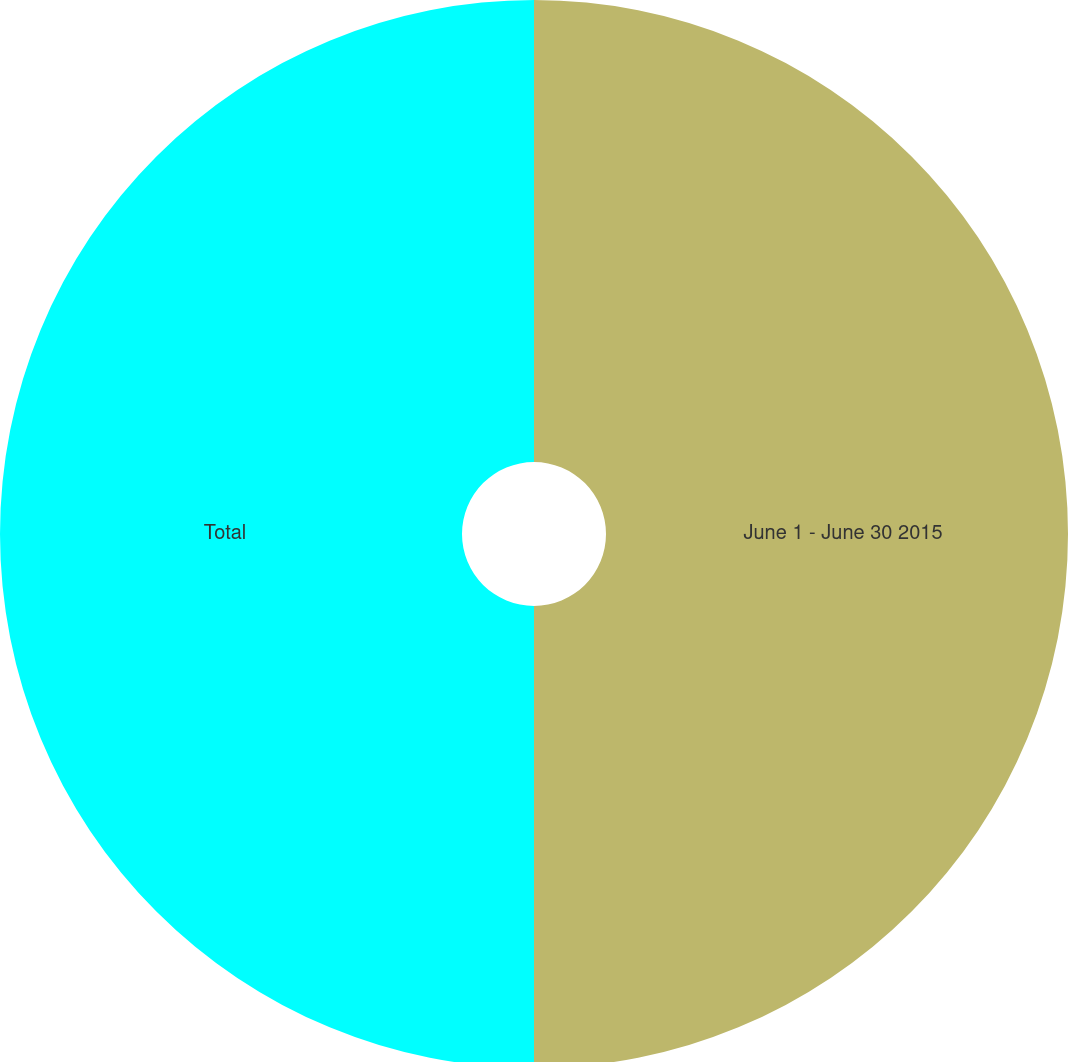Convert chart to OTSL. <chart><loc_0><loc_0><loc_500><loc_500><pie_chart><fcel>June 1 - June 30 2015<fcel>Total<nl><fcel>50.0%<fcel>50.0%<nl></chart> 